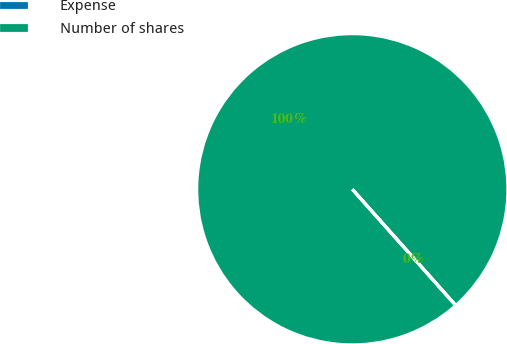Convert chart to OTSL. <chart><loc_0><loc_0><loc_500><loc_500><pie_chart><fcel>Expense<fcel>Number of shares<nl><fcel>0.01%<fcel>99.99%<nl></chart> 